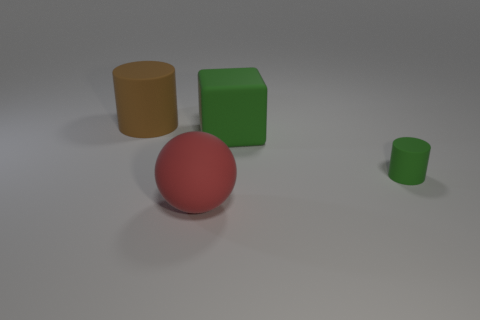Add 4 small blue metallic blocks. How many objects exist? 8 Subtract all cubes. How many objects are left? 3 Subtract 0 cyan cylinders. How many objects are left? 4 Subtract 1 spheres. How many spheres are left? 0 Subtract all blue cylinders. Subtract all blue cubes. How many cylinders are left? 2 Subtract all green matte cylinders. Subtract all red rubber objects. How many objects are left? 2 Add 4 brown objects. How many brown objects are left? 5 Add 3 big cyan metal cubes. How many big cyan metal cubes exist? 3 